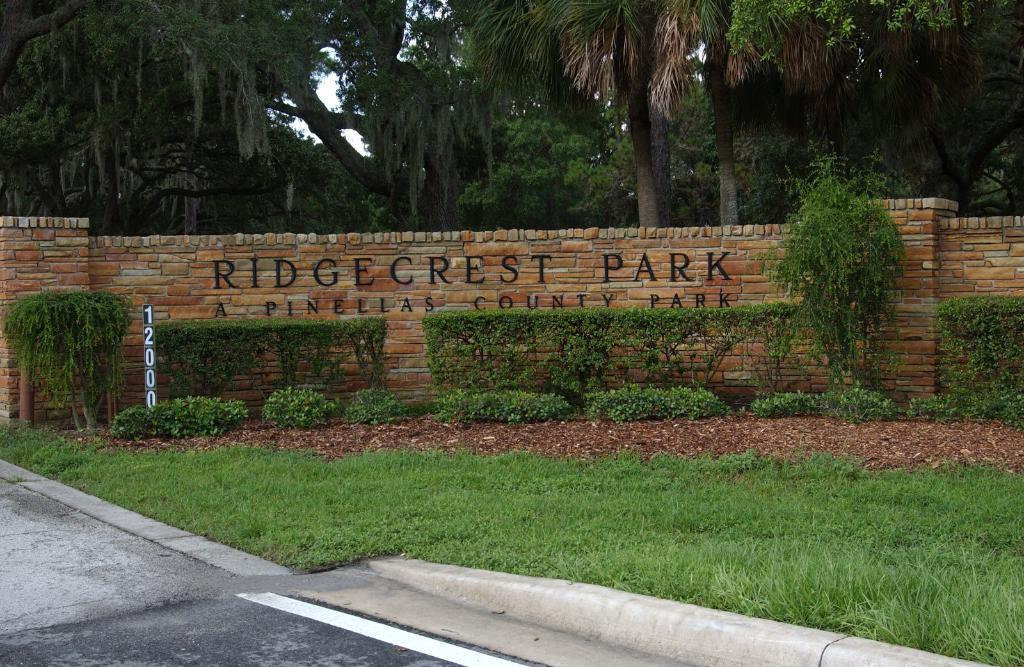What is located in the center of the image? In the center of the image, there is a wall, bushes, a board, dry leaves, and grass. What type of vegetation can be seen in the center of the image? Bushes and grass are visible in the center of the image. What is present on the board in the center of the image? The facts provided do not specify what is on the board. What can be seen in the background of the image? Trees are present in the background of the image. What is visible at the bottom of the image? A road is visible at the bottom of the image. How many stars can be seen in the image? There are no stars visible in the image. What type of expert is present in the image? There is no expert present in the image. 